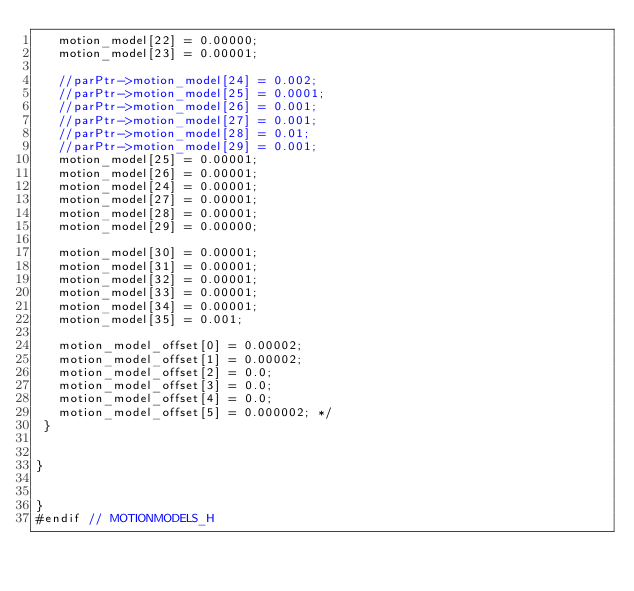<code> <loc_0><loc_0><loc_500><loc_500><_C_>   motion_model[22] = 0.00000;
   motion_model[23] = 0.00001;

   //parPtr->motion_model[24] = 0.002;
   //parPtr->motion_model[25] = 0.0001;
   //parPtr->motion_model[26] = 0.001;
   //parPtr->motion_model[27] = 0.001;
   //parPtr->motion_model[28] = 0.01;
   //parPtr->motion_model[29] = 0.001;
   motion_model[25] = 0.00001;
   motion_model[26] = 0.00001;
   motion_model[24] = 0.00001;
   motion_model[27] = 0.00001;
   motion_model[28] = 0.00001;
   motion_model[29] = 0.00000;

   motion_model[30] = 0.00001;
   motion_model[31] = 0.00001;
   motion_model[32] = 0.00001;
   motion_model[33] = 0.00001;
   motion_model[34] = 0.00001;
   motion_model[35] = 0.001;

   motion_model_offset[0] = 0.00002;
   motion_model_offset[1] = 0.00002;
   motion_model_offset[2] = 0.0;
   motion_model_offset[3] = 0.0;
   motion_model_offset[4] = 0.0;
   motion_model_offset[5] = 0.000002; */
 }


}


}
#endif // MOTIONMODELS_H
</code> 